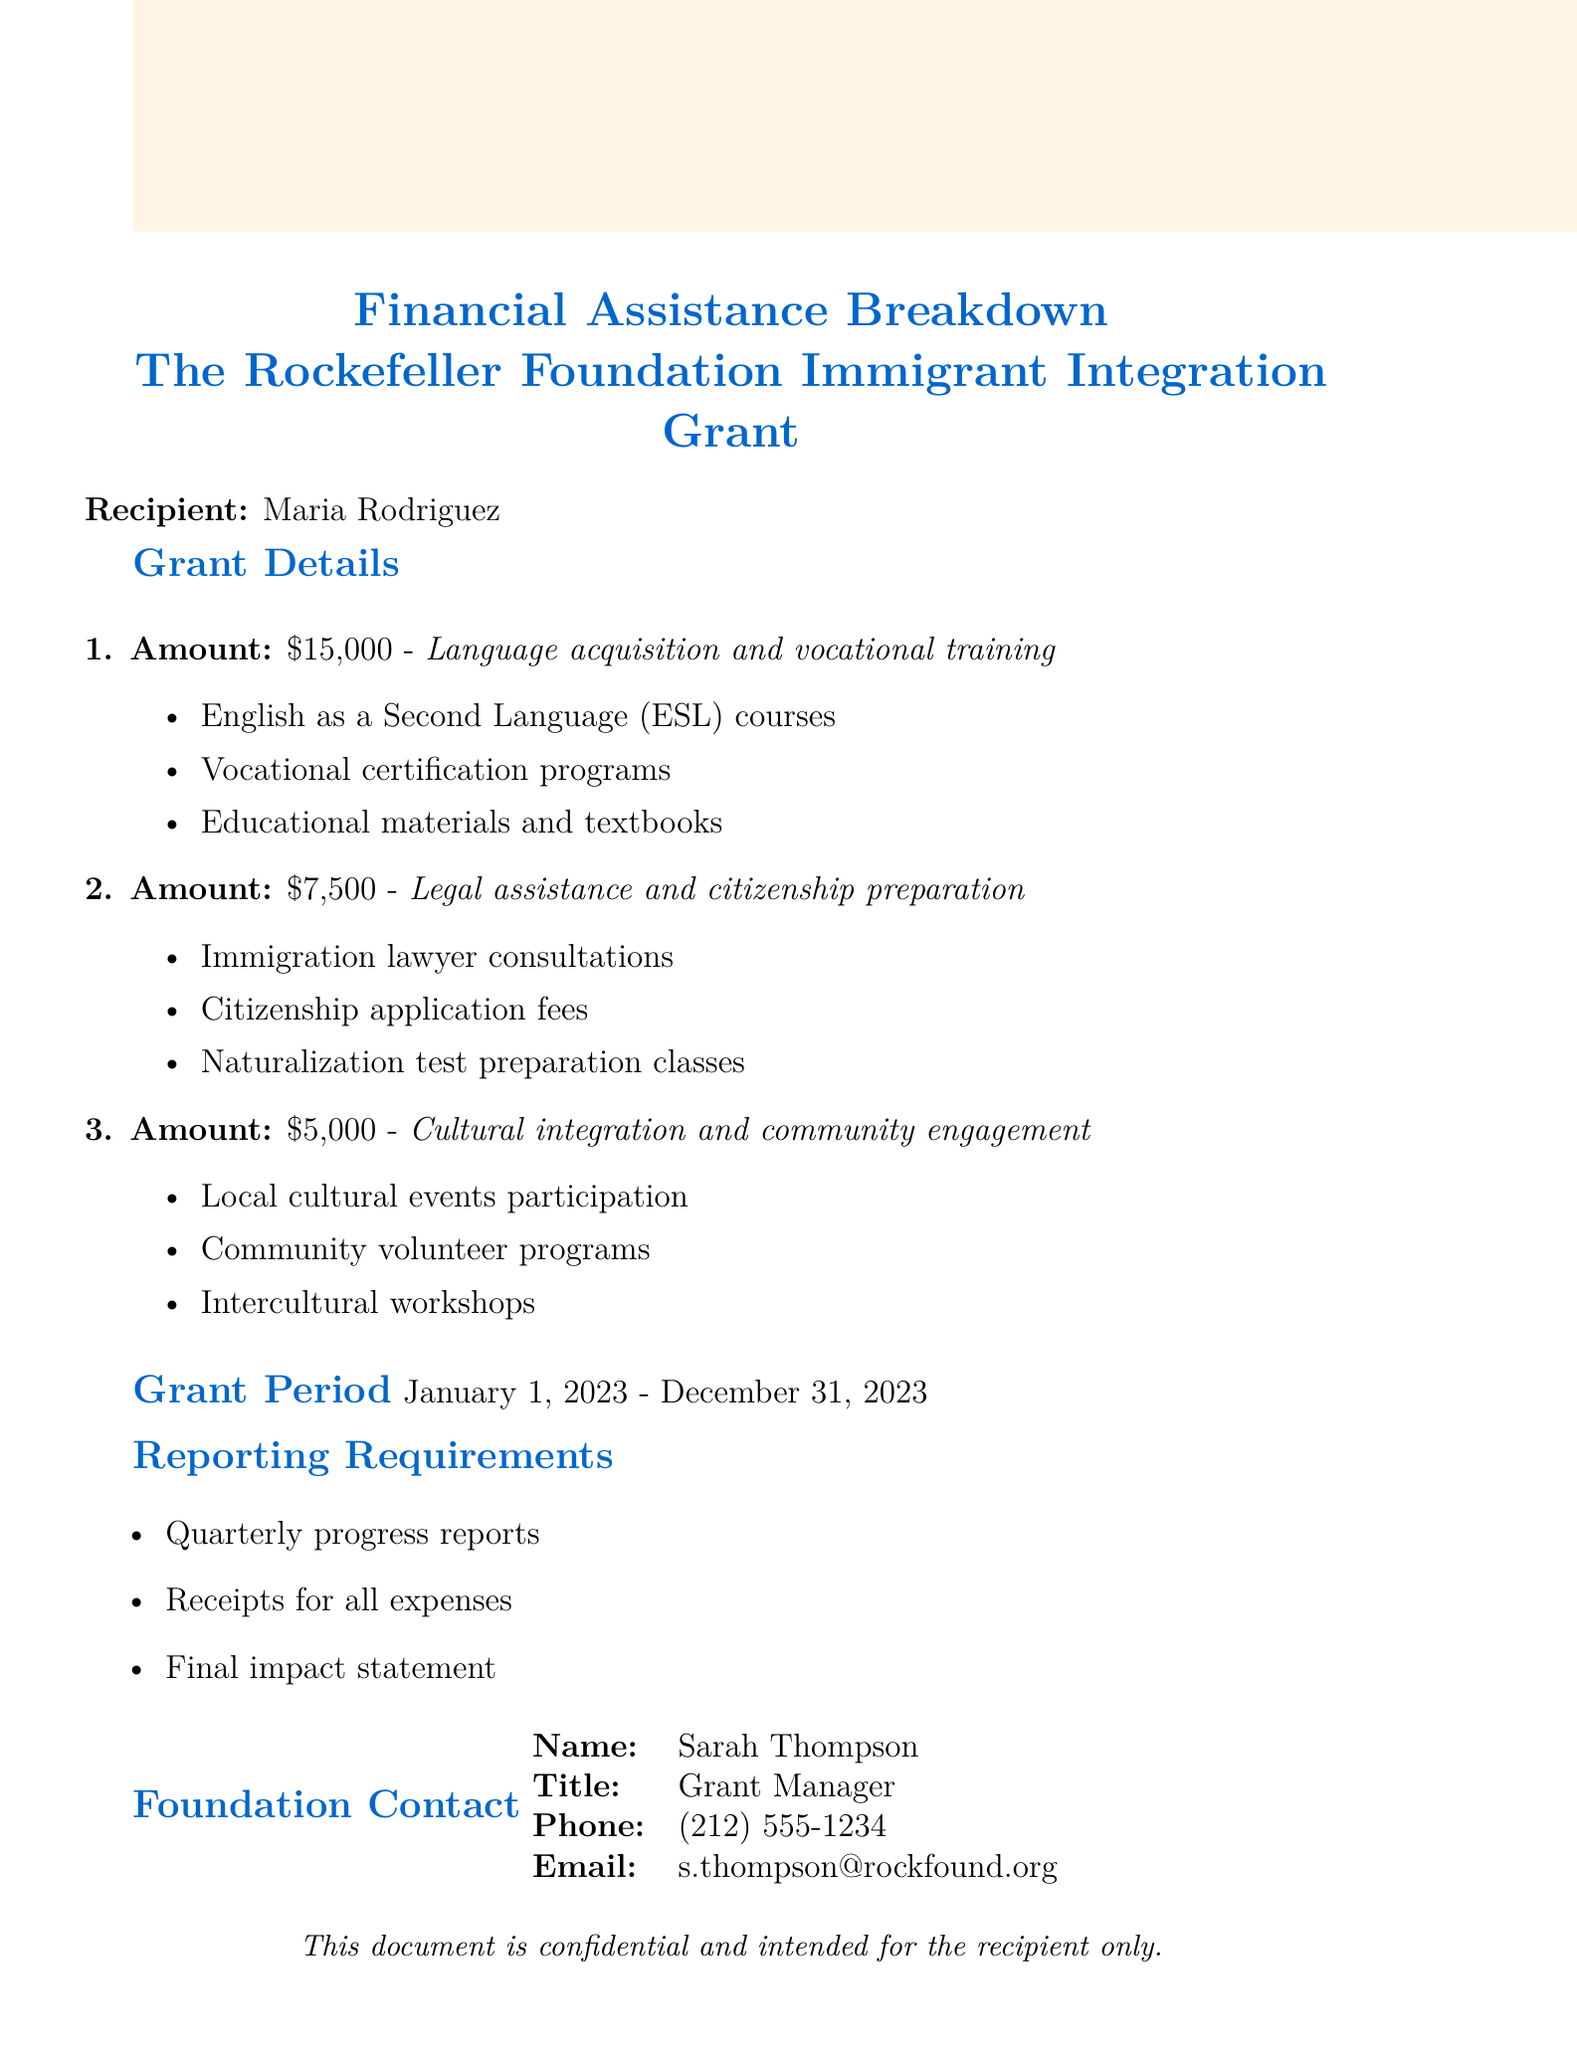What is the total grant amount? The total grant amount is the sum of all individual grants listed: $15,000 + $7,500 + $5,000 = $27,500.
Answer: $27,500 Who is the grant recipient? The document specifies the recipient of the financial assistance as Maria Rodriguez.
Answer: Maria Rodriguez What is the contact email for the foundation? The document provides the email address of the grant manager, which is s.thompson@rockfound.org.
Answer: s.thompson@rockfound.org What type of training is included in the largest grant? The largest grant of $15,000 allows for language acquisition and vocational training.
Answer: Language acquisition and vocational training What are the reporting requirements mentioned? The document lists quarterly progress reports, receipts for all expenses, and a final impact statement as the reporting requirements.
Answer: Quarterly progress reports, receipts for all expenses, final impact statement How long is the grant period? The grant period is explicitly stated in the document, running from January 1, 2023, to December 31, 2023.
Answer: January 1, 2023 - December 31, 2023 What is the amount allocated for legal assistance? The amount specifically allocated for legal assistance and citizenship preparation is $7,500.
Answer: $7,500 Who is the grant manager? The document identifies the person in charge as Sarah Thompson, the Grant Manager.
Answer: Sarah Thompson 